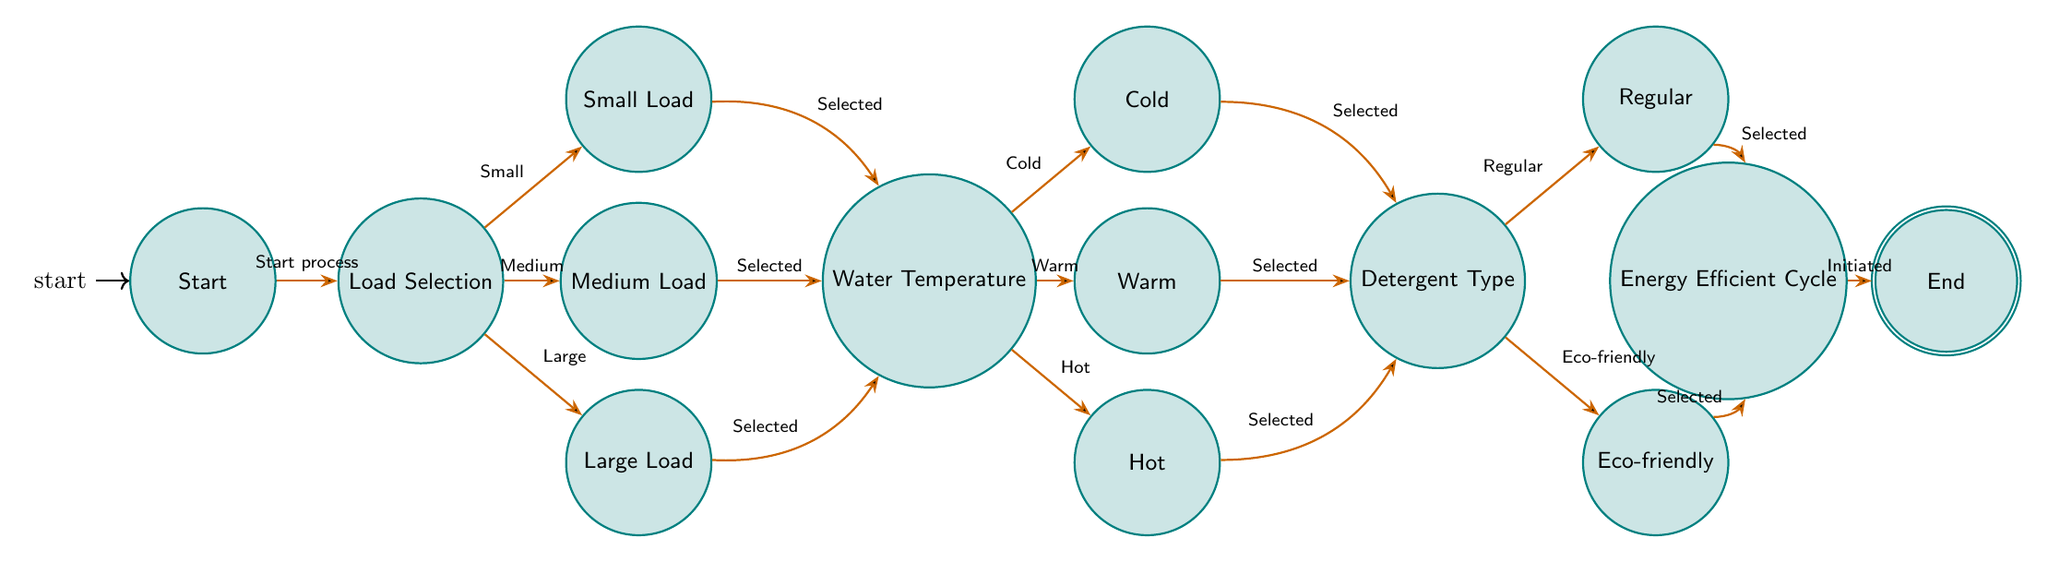What's the first state in the diagram? The diagram starts with the "Start" state, as indicated by the arrow labeled "Start process" leading to the next state.
Answer: Start How many load options are available? There are three load options available: Small Load, Medium Load, and Large Load, as seen in the "Load Selection" state.
Answer: 3 Which state follows after selecting a Large Load? After selecting a Large Load, the next state is "Water Temperature," as there is a transition from "Large Load" to "Water Temperature."
Answer: Water Temperature What types of water temperatures can be selected? The diagram shows three types of water temperatures that can be selected: Cold, Warm, and Hot, connected to the "Water Temperature" state.
Answer: Cold, Warm, Hot What happens after selecting Eco-friendly Detergent? After selecting Eco-friendly Detergent, the next state is "Energy Efficient Cycle," as indicated by the transition from "EcoFriendlyDetergent" to "EnergyEfficientCycle."
Answer: Energy Efficient Cycle Which state is the last one in the flow? The last state in the flow is "End," which is the accepting state where the process concludes after initiating the energy-efficient cycle.
Answer: End How do you transition from "Warm" to "Detergent Type"? From the "Warm" state, you move to the "Detergent Type" state upon selecting Warm Water, as shown by the transition indicating "Selected."
Answer: Detergent Type What kind of detergents can be chosen? The diagram presents two types of detergents that can be chosen: Regular Detergent and Eco-friendly Detergent, as indicated in the "Detergent Type" state.
Answer: Regular Detergent, Eco-friendly Detergent How many states are involved in the energy-efficient washing cycle process? There are a total of 12 states in the diagram, counting from "Start" to "End."
Answer: 12 